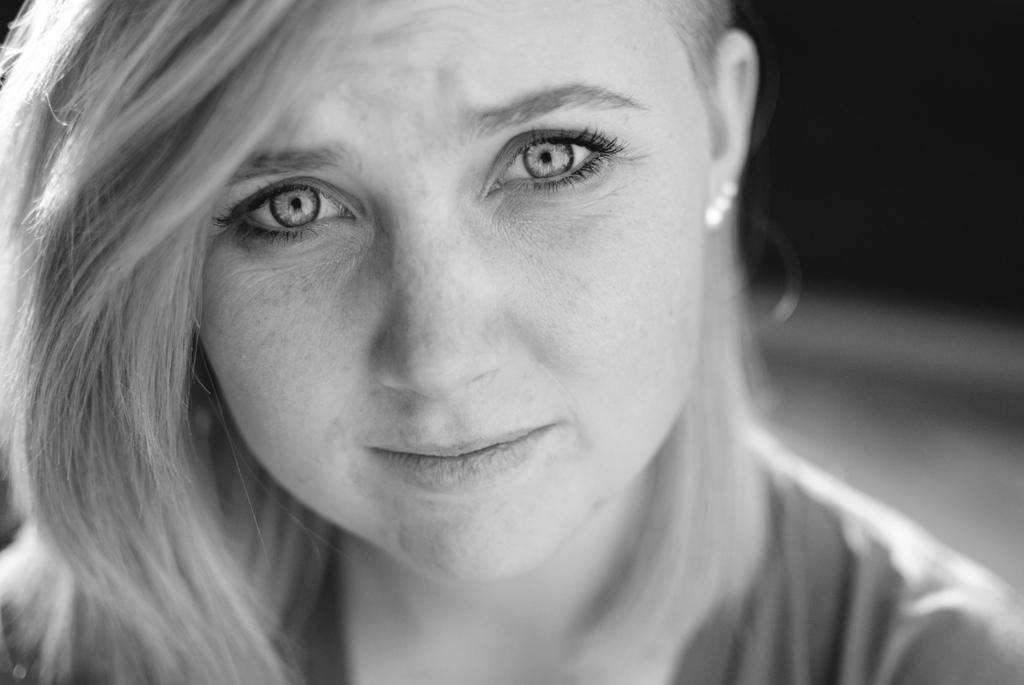What is the color scheme of the image? The image is black and white. What is the main subject of the image? The image depicts a woman's face. What type of health issues can be seen affecting the woman's face in the image? There are no health issues visible on the woman's face in the image. What type of pipe is the woman holding in the image? There is no pipe present in the image. What emotion does the woman appear to be feeling in the image? The provided facts do not mention any specific emotions or regrets. 